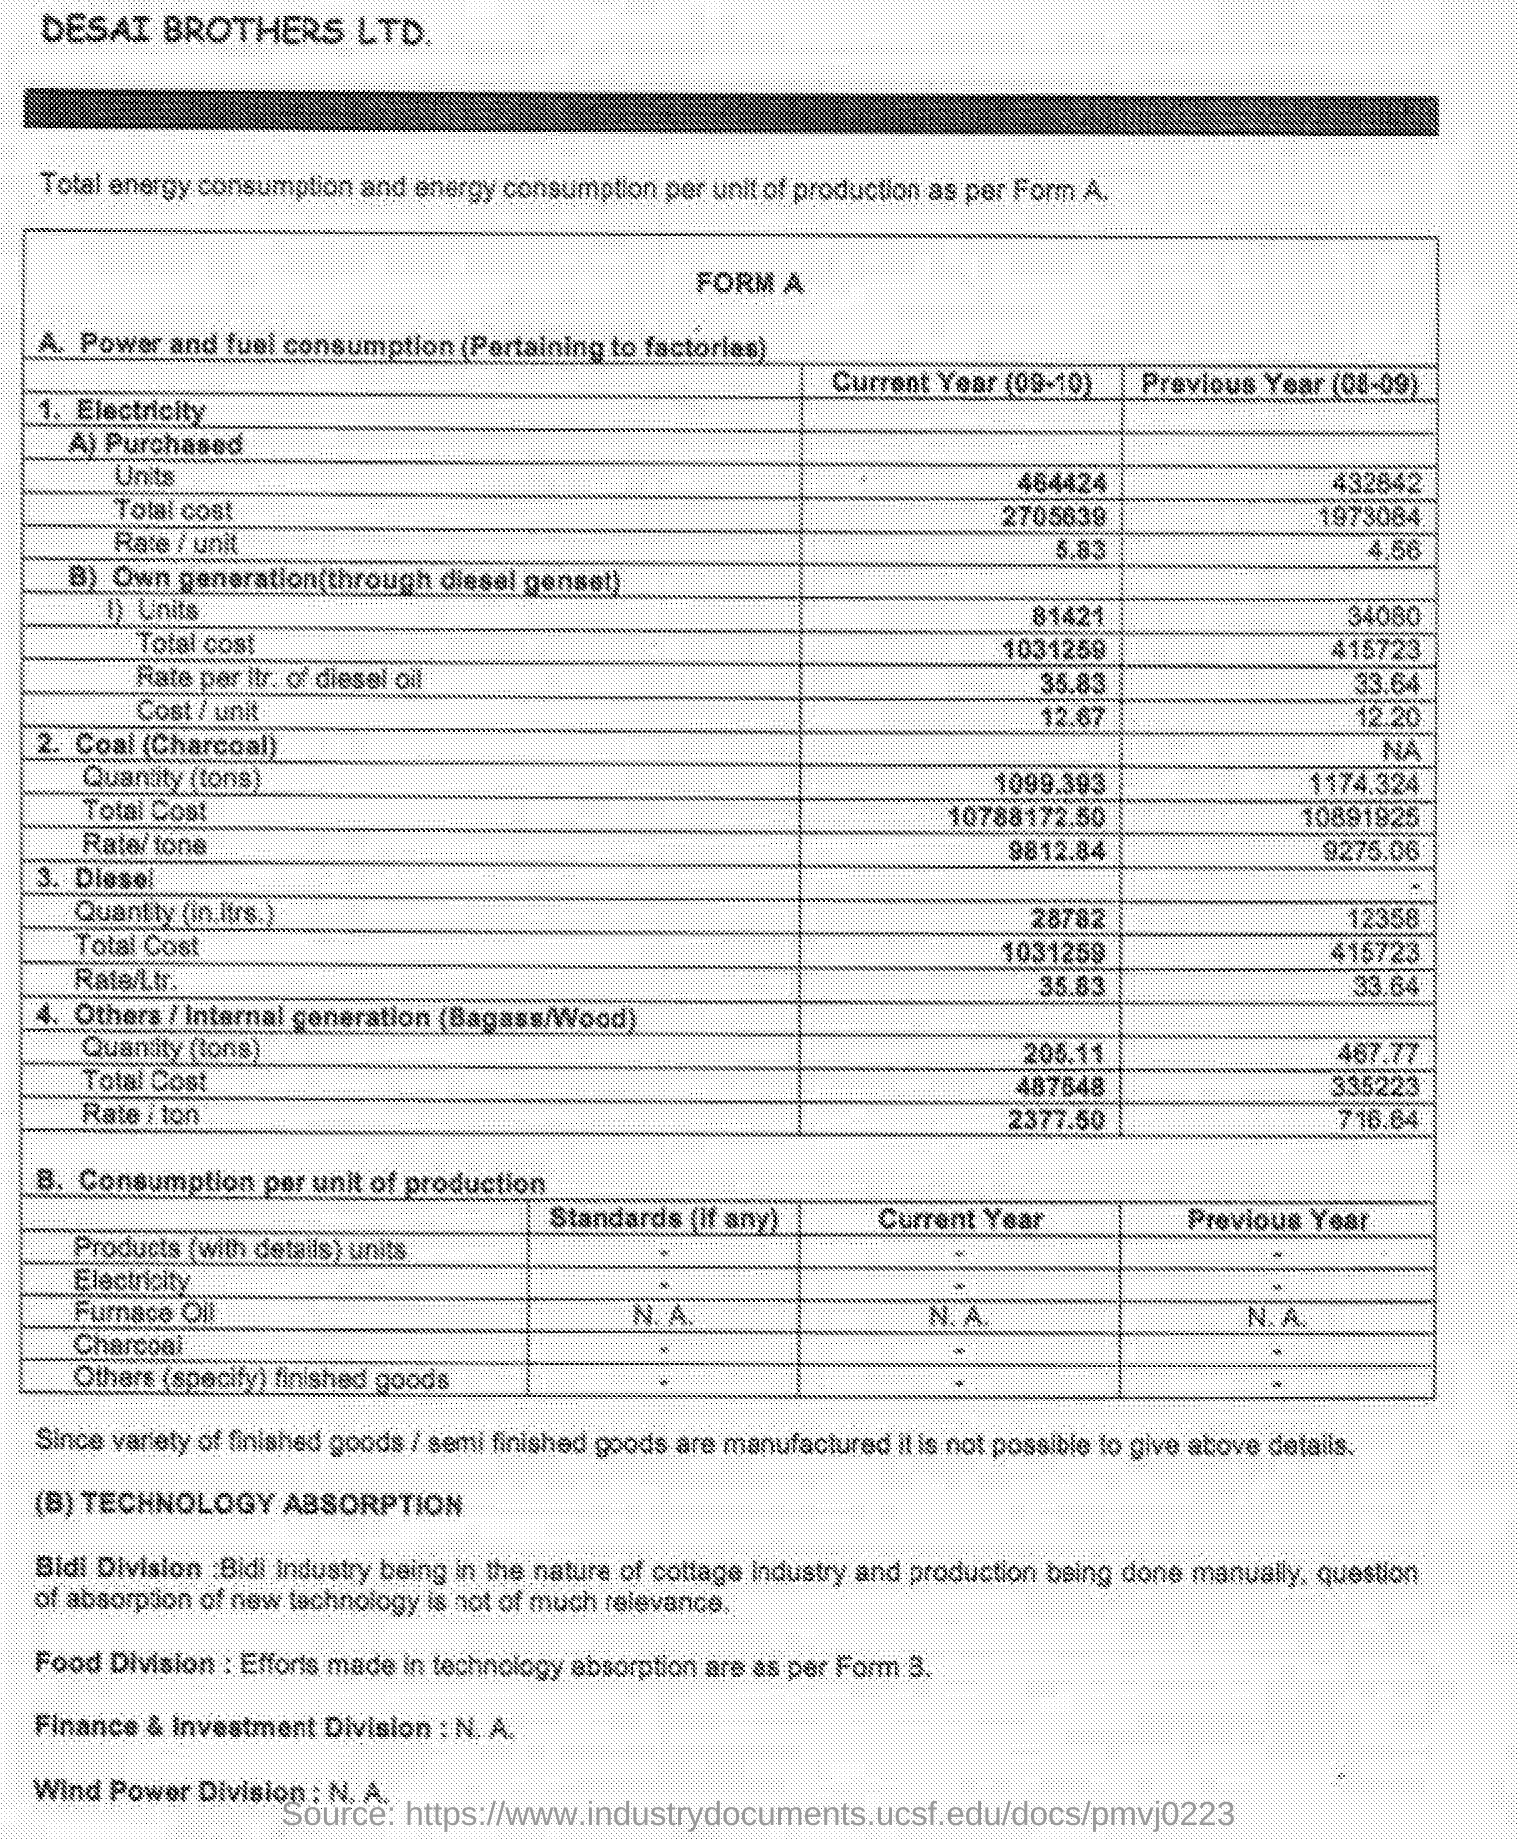Point out several critical features in this image. In the current year (2009-2010), the rate for diesel per litre is 35.83. In the current year, 2009-2010, the quantity of coal (charcoal) was 1099.393 tons. The quantity of diesel in the previous year (2008-2009) was 12,358 liters. The previous year's rate for diesel was 33.64 rupees per liter. The total cost for coal (charcoal) in the current year (2009-2010) is 107,881,72.50. 